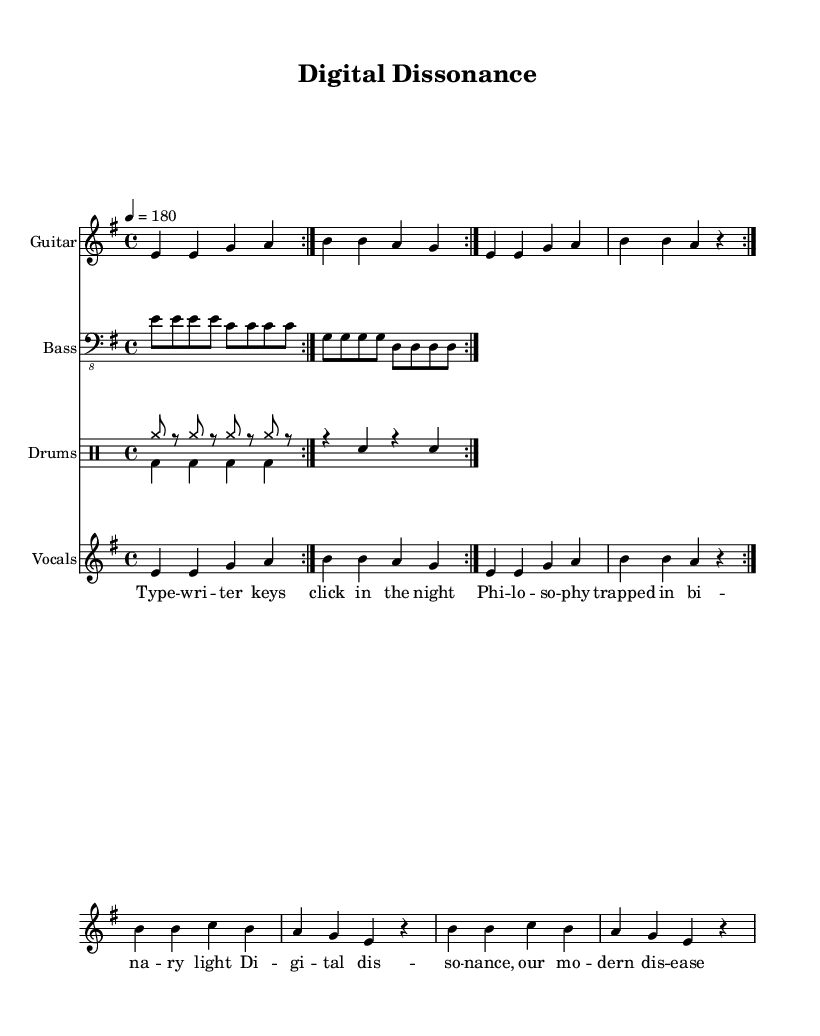What is the key signature of this music? The key signature is indicated at the beginning of the score. It shows two sharps, which corresponds to E minor.
Answer: E minor What is the time signature of this composition? The time signature is found at the beginning, next to the key signature. It shows a "4" over a "4," indicating four beats per measure.
Answer: 4/4 What is the tempo marking of the piece? The tempo marking is explicitly stated as "4 = 180," which indicates the number of beats per minute.
Answer: 180 How many measures are in the verse section? The verse is defined in the lyrics section, which has four lines, and counting the repetitions shows eight measures in total.
Answer: 8 What instrument is notated as "Bass" in the score? The instrument labeled "Bass" in the score is always written in bass clef, and it's indicated by the specific instrument name on the staff.
Answer: Bass Guitar What type of music structure does the composition follow? The structure includes a verse followed by a chorus, typical in rock music, which emphasizes the call-and-response nature of the lyrics.
Answer: Verse-Chorus How does the drum part contribute to the rock style? The drum section features a driving beat with bass drum and snare interactions, common in rock to create a strong rhythmic foundation.
Answer: Driving beat 